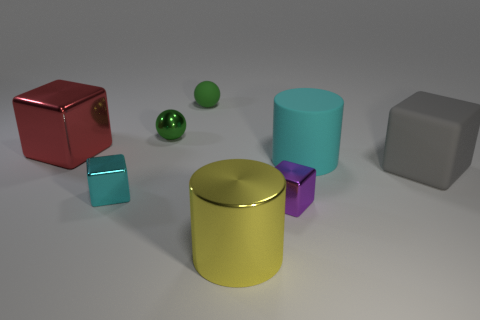What could be the potential use of these objects? The objects seem to be geometric shapes typically used for educational purposes, such as teaching about volumes, shapes, and the properties of materials. However, in a more abstract context, they could also serve as decorative elements or be part of a visual composition exploring color and form in 3D design and art installations. 